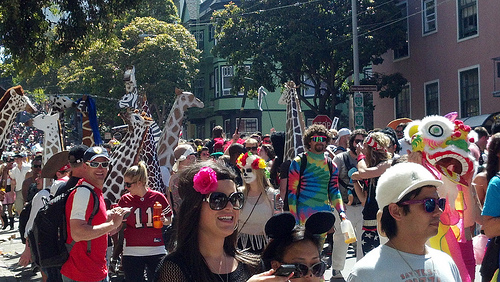<image>
Is the stop sign next to the tree? No. The stop sign is not positioned next to the tree. They are located in different areas of the scene. 